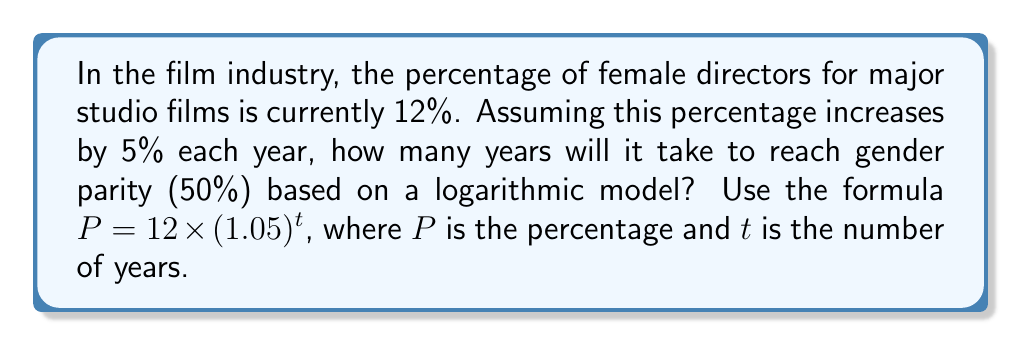Show me your answer to this math problem. To solve this problem, we'll use the logarithmic model given and follow these steps:

1) We want to find $t$ when $P = 50\%$. Let's set up the equation:
   $50 = 12 \times (1.05)^t$

2) Divide both sides by 12:
   $\frac{50}{12} = (1.05)^t$

3) Take the natural logarithm of both sides:
   $\ln(\frac{50}{12}) = \ln((1.05)^t)$

4) Use the logarithm property $\ln(a^b) = b\ln(a)$:
   $\ln(\frac{50}{12}) = t\ln(1.05)$

5) Solve for $t$:
   $t = \frac{\ln(\frac{50}{12})}{\ln(1.05)}$

6) Calculate the value:
   $t = \frac{\ln(4.1667)}{\ln(1.05)} \approx 28.97$

7) Since we can only have whole years, we round up to the nearest integer:
   $t = 29$ years
Answer: 29 years 